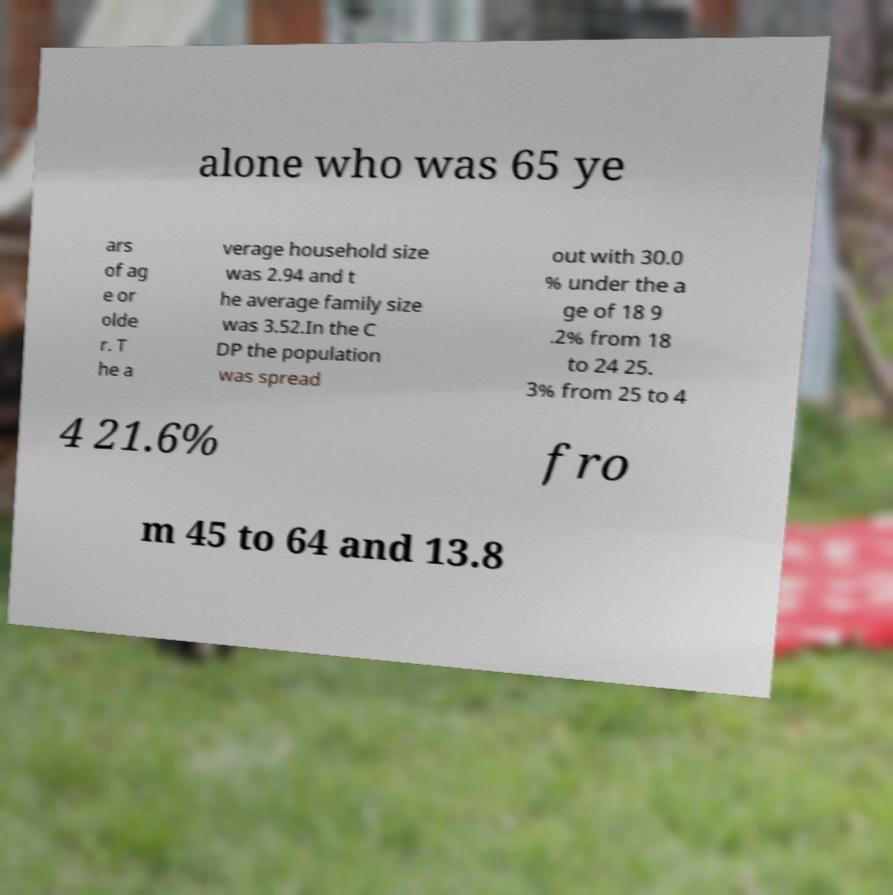For documentation purposes, I need the text within this image transcribed. Could you provide that? alone who was 65 ye ars of ag e or olde r. T he a verage household size was 2.94 and t he average family size was 3.52.In the C DP the population was spread out with 30.0 % under the a ge of 18 9 .2% from 18 to 24 25. 3% from 25 to 4 4 21.6% fro m 45 to 64 and 13.8 